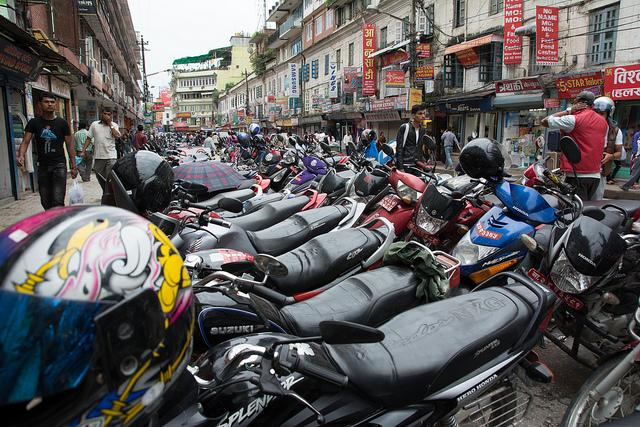The motorbikes on this bustling city street are present in which country?

Choices:
A) china
B) thailand
C) vietnam
D) india india 